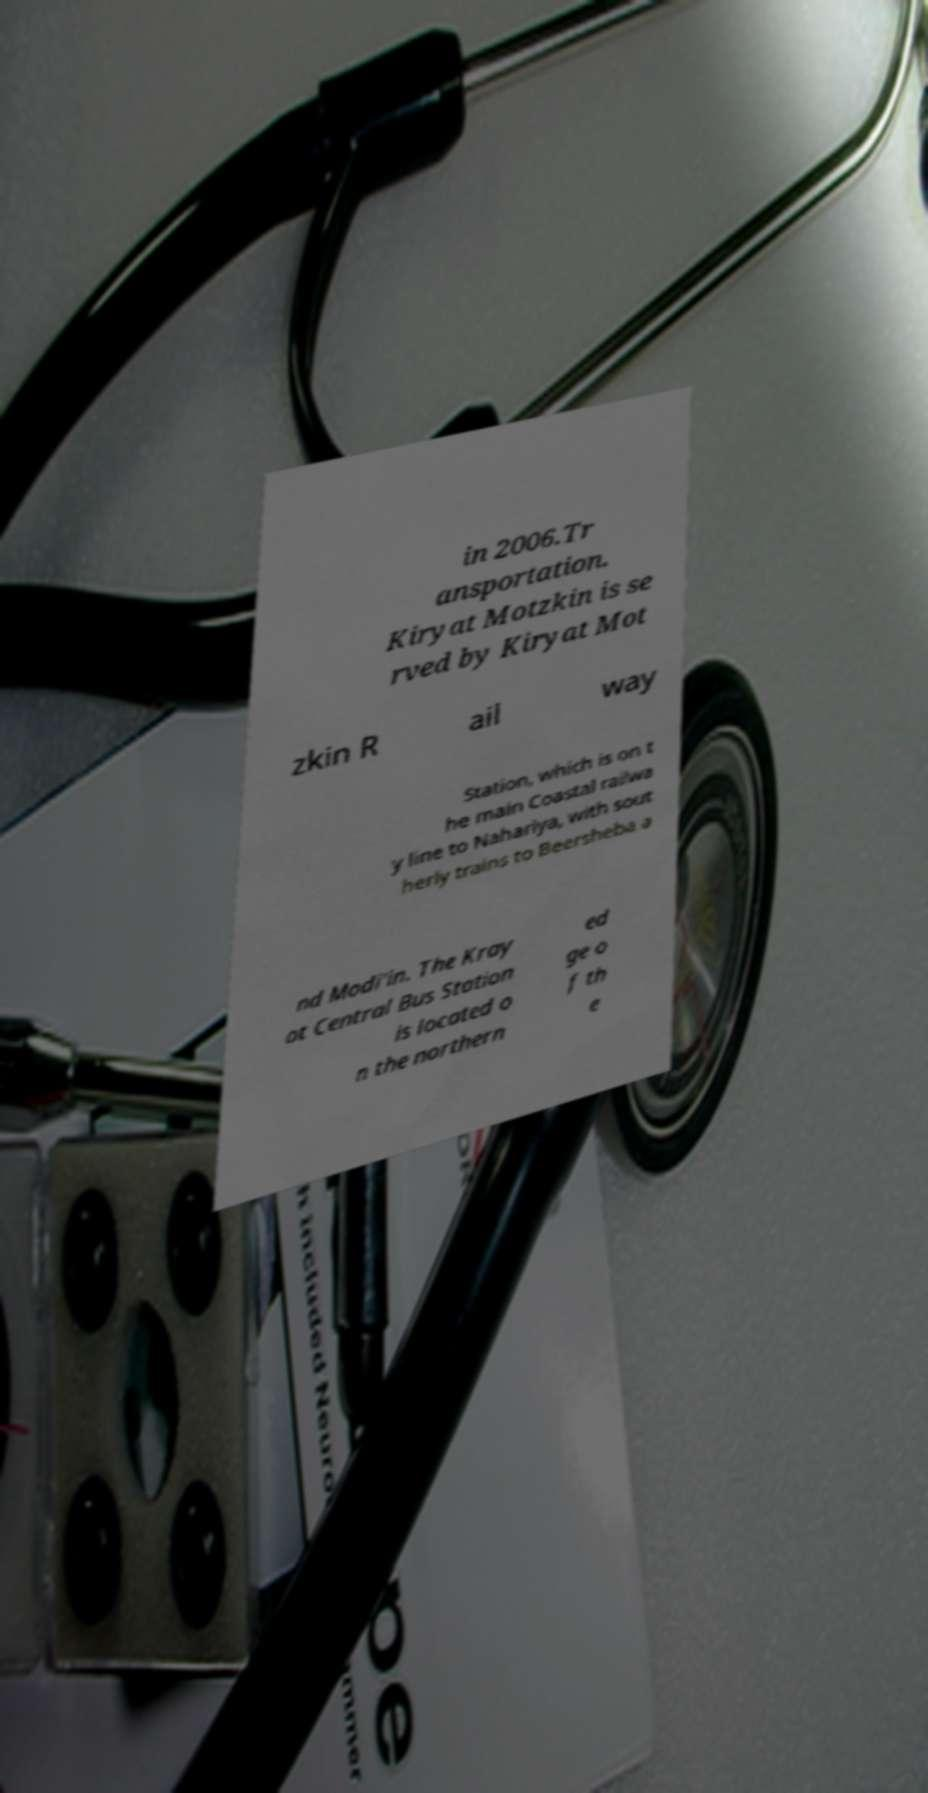Can you accurately transcribe the text from the provided image for me? in 2006.Tr ansportation. Kiryat Motzkin is se rved by Kiryat Mot zkin R ail way Station, which is on t he main Coastal railwa y line to Nahariya, with sout herly trains to Beersheba a nd Modi'in. The Kray ot Central Bus Station is located o n the northern ed ge o f th e 